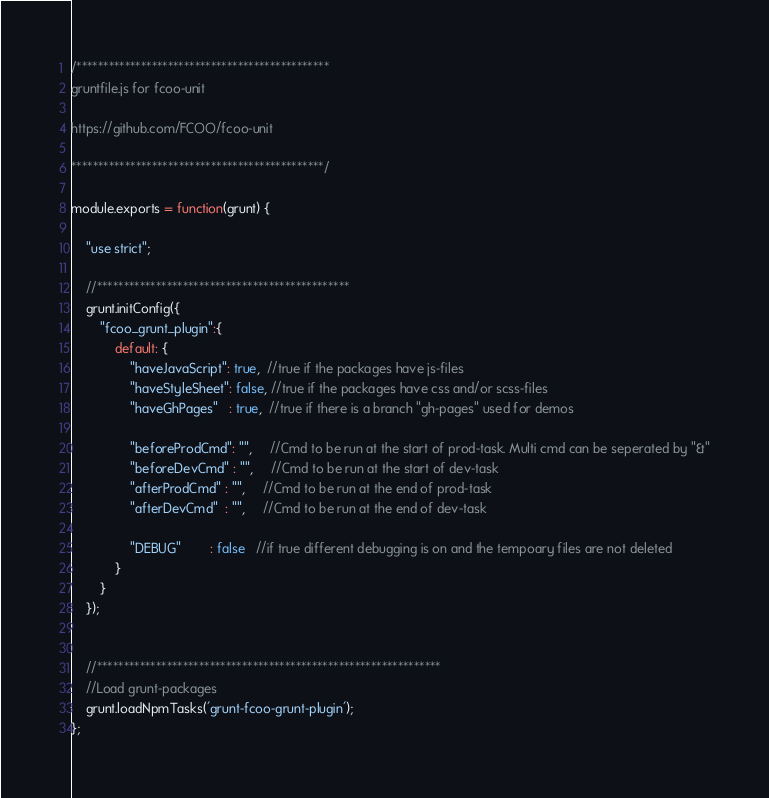<code> <loc_0><loc_0><loc_500><loc_500><_JavaScript_>/***********************************************
gruntfile.js for fcoo-unit

https://github.com/FCOO/fcoo-unit

***********************************************/

module.exports = function(grunt) {

    "use strict";

    //***********************************************
    grunt.initConfig({
        "fcoo_grunt_plugin":{
            default: {
                "haveJavaScript": true,  //true if the packages have js-files
                "haveStyleSheet": false, //true if the packages have css and/or scss-files
                "haveGhPages"   : true,  //true if there is a branch "gh-pages" used for demos

                "beforeProdCmd": "",     //Cmd to be run at the start of prod-task. Multi cmd can be seperated by "&"
                "beforeDevCmd" : "",     //Cmd to be run at the start of dev-task
                "afterProdCmd" : "",     //Cmd to be run at the end of prod-task
                "afterDevCmd"  : "",     //Cmd to be run at the end of dev-task

                "DEBUG"        : false   //if true different debugging is on and the tempoary files are not deleted
            }
        }
    });


    //****************************************************************
    //Load grunt-packages
    grunt.loadNpmTasks('grunt-fcoo-grunt-plugin');
};</code> 